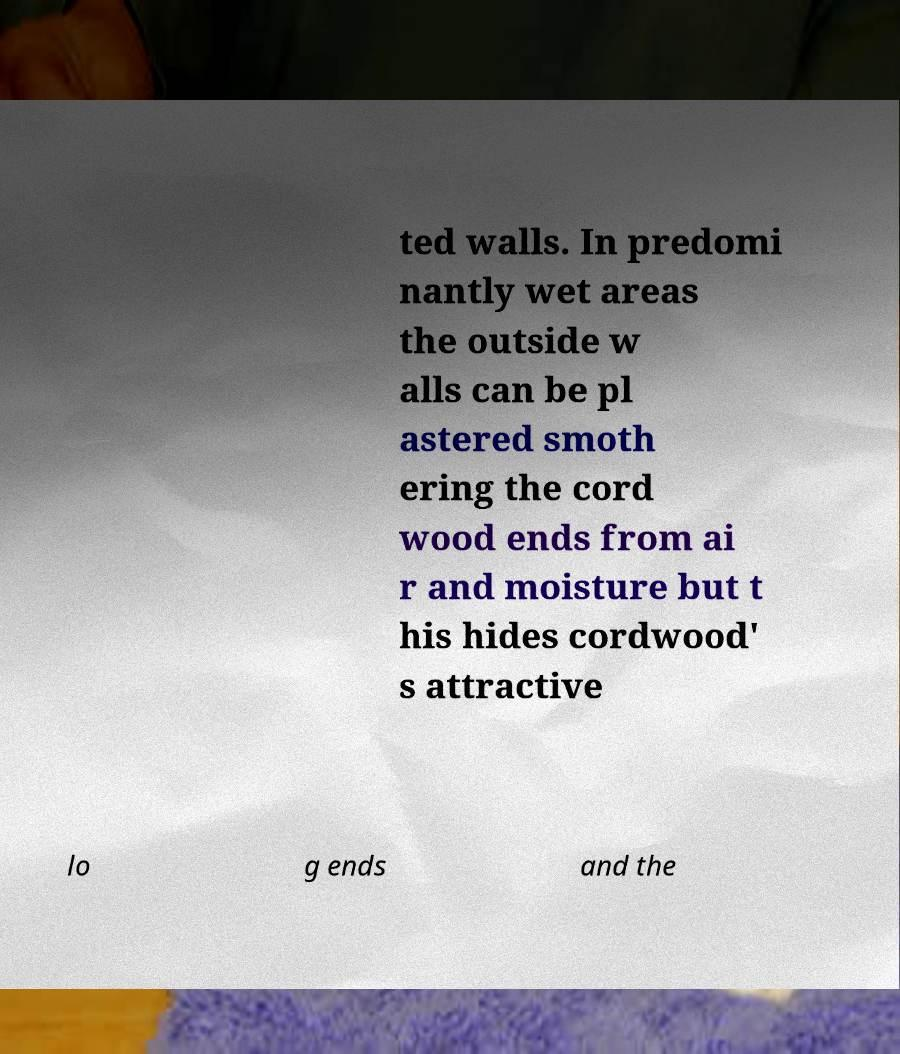There's text embedded in this image that I need extracted. Can you transcribe it verbatim? ted walls. In predomi nantly wet areas the outside w alls can be pl astered smoth ering the cord wood ends from ai r and moisture but t his hides cordwood' s attractive lo g ends and the 